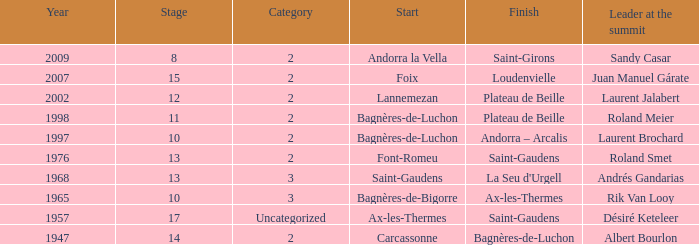Could you parse the entire table? {'header': ['Year', 'Stage', 'Category', 'Start', 'Finish', 'Leader at the summit'], 'rows': [['2009', '8', '2', 'Andorra la Vella', 'Saint-Girons', 'Sandy Casar'], ['2007', '15', '2', 'Foix', 'Loudenvielle', 'Juan Manuel Gárate'], ['2002', '12', '2', 'Lannemezan', 'Plateau de Beille', 'Laurent Jalabert'], ['1998', '11', '2', 'Bagnères-de-Luchon', 'Plateau de Beille', 'Roland Meier'], ['1997', '10', '2', 'Bagnères-de-Luchon', 'Andorra – Arcalis', 'Laurent Brochard'], ['1976', '13', '2', 'Font-Romeu', 'Saint-Gaudens', 'Roland Smet'], ['1968', '13', '3', 'Saint-Gaudens', "La Seu d'Urgell", 'Andrés Gandarias'], ['1965', '10', '3', 'Bagnères-de-Bigorre', 'Ax-les-Thermes', 'Rik Van Looy'], ['1957', '17', 'Uncategorized', 'Ax-les-Thermes', 'Saint-Gaudens', 'Désiré Keteleer'], ['1947', '14', '2', 'Carcassonne', 'Bagnères-de-Luchon', 'Albert Bourlon']]} Supply the end for years post-200 Saint-Girons. 